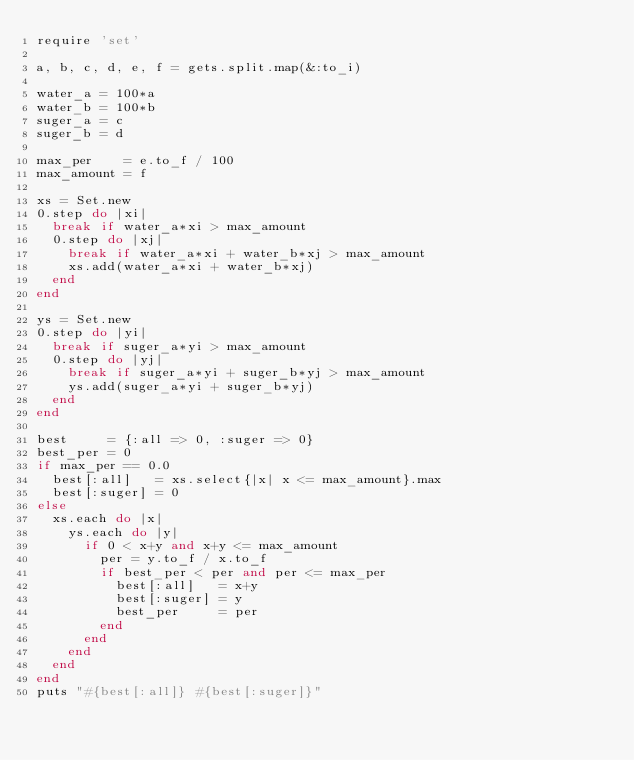<code> <loc_0><loc_0><loc_500><loc_500><_Ruby_>require 'set'

a, b, c, d, e, f = gets.split.map(&:to_i)

water_a = 100*a
water_b = 100*b
suger_a = c
suger_b = d

max_per    = e.to_f / 100
max_amount = f

xs = Set.new
0.step do |xi|
  break if water_a*xi > max_amount
  0.step do |xj|
    break if water_a*xi + water_b*xj > max_amount
    xs.add(water_a*xi + water_b*xj)
  end
end

ys = Set.new
0.step do |yi|
  break if suger_a*yi > max_amount
  0.step do |yj|
    break if suger_a*yi + suger_b*yj > max_amount
    ys.add(suger_a*yi + suger_b*yj)
  end
end

best     = {:all => 0, :suger => 0}
best_per = 0
if max_per == 0.0
  best[:all]   = xs.select{|x| x <= max_amount}.max
  best[:suger] = 0
else
  xs.each do |x|
    ys.each do |y|
      if 0 < x+y and x+y <= max_amount
        per = y.to_f / x.to_f
        if best_per < per and per <= max_per
          best[:all]   = x+y
          best[:suger] = y
          best_per     = per
        end
      end
    end
  end
end
puts "#{best[:all]} #{best[:suger]}"
</code> 